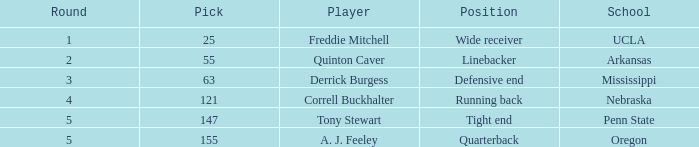What position did the player who was picked in round 3 play? Defensive end. 